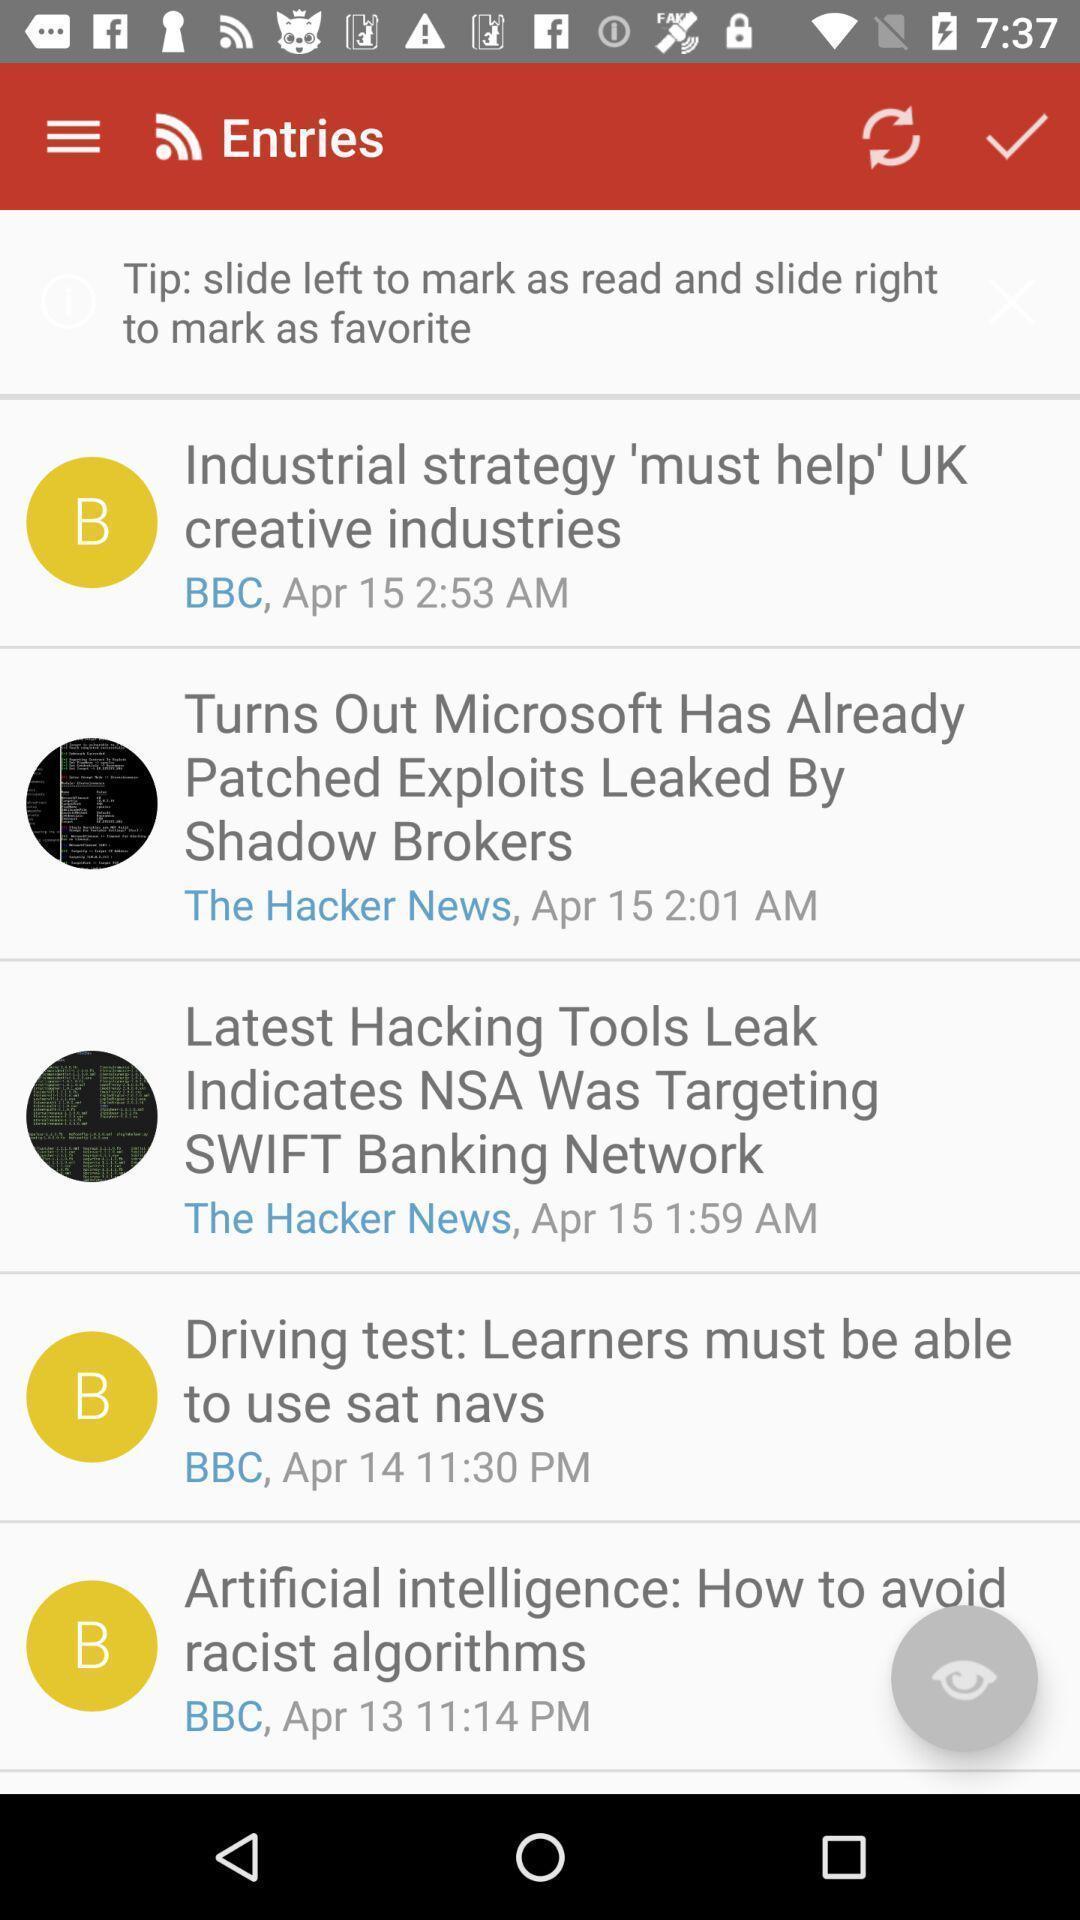Provide a description of this screenshot. Page displaying list of news updates. 